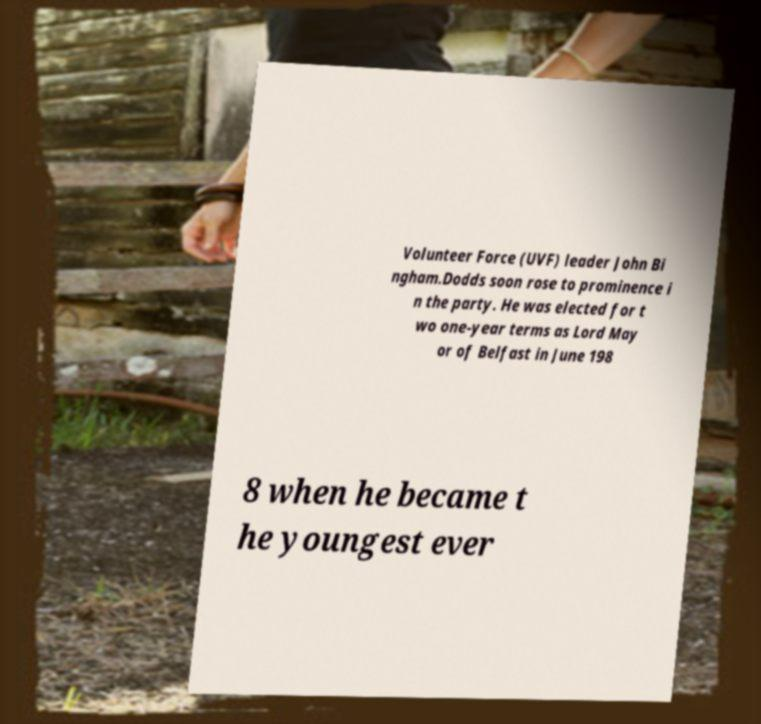Can you read and provide the text displayed in the image?This photo seems to have some interesting text. Can you extract and type it out for me? Volunteer Force (UVF) leader John Bi ngham.Dodds soon rose to prominence i n the party. He was elected for t wo one-year terms as Lord May or of Belfast in June 198 8 when he became t he youngest ever 